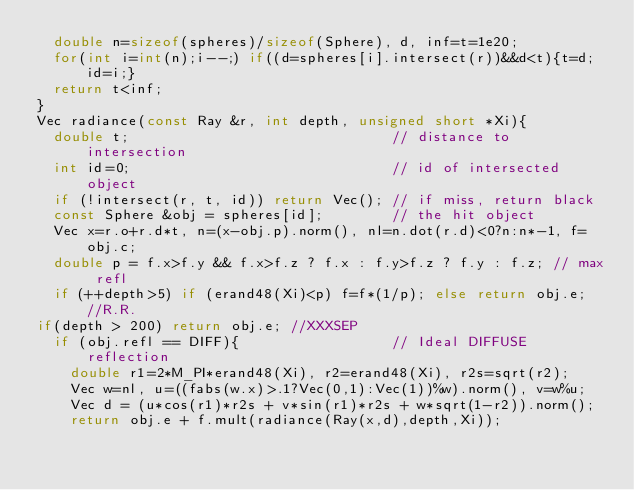<code> <loc_0><loc_0><loc_500><loc_500><_C++_>  double n=sizeof(spheres)/sizeof(Sphere), d, inf=t=1e20;
  for(int i=int(n);i--;) if((d=spheres[i].intersect(r))&&d<t){t=d;id=i;}
  return t<inf;
}
Vec radiance(const Ray &r, int depth, unsigned short *Xi){
  double t;                               // distance to intersection
  int id=0;                               // id of intersected object
  if (!intersect(r, t, id)) return Vec(); // if miss, return black
  const Sphere &obj = spheres[id];        // the hit object
  Vec x=r.o+r.d*t, n=(x-obj.p).norm(), nl=n.dot(r.d)<0?n:n*-1, f=obj.c;
  double p = f.x>f.y && f.x>f.z ? f.x : f.y>f.z ? f.y : f.z; // max refl
  if (++depth>5) if (erand48(Xi)<p) f=f*(1/p); else return obj.e; //R.R.
if(depth > 200) return obj.e; //XXXSEP
  if (obj.refl == DIFF){                  // Ideal DIFFUSE reflection
    double r1=2*M_PI*erand48(Xi), r2=erand48(Xi), r2s=sqrt(r2);
    Vec w=nl, u=((fabs(w.x)>.1?Vec(0,1):Vec(1))%w).norm(), v=w%u;
    Vec d = (u*cos(r1)*r2s + v*sin(r1)*r2s + w*sqrt(1-r2)).norm();
    return obj.e + f.mult(radiance(Ray(x,d),depth,Xi));</code> 